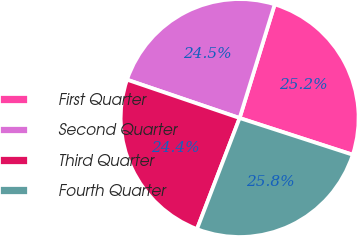<chart> <loc_0><loc_0><loc_500><loc_500><pie_chart><fcel>First Quarter<fcel>Second Quarter<fcel>Third Quarter<fcel>Fourth Quarter<nl><fcel>25.23%<fcel>24.54%<fcel>24.39%<fcel>25.84%<nl></chart> 